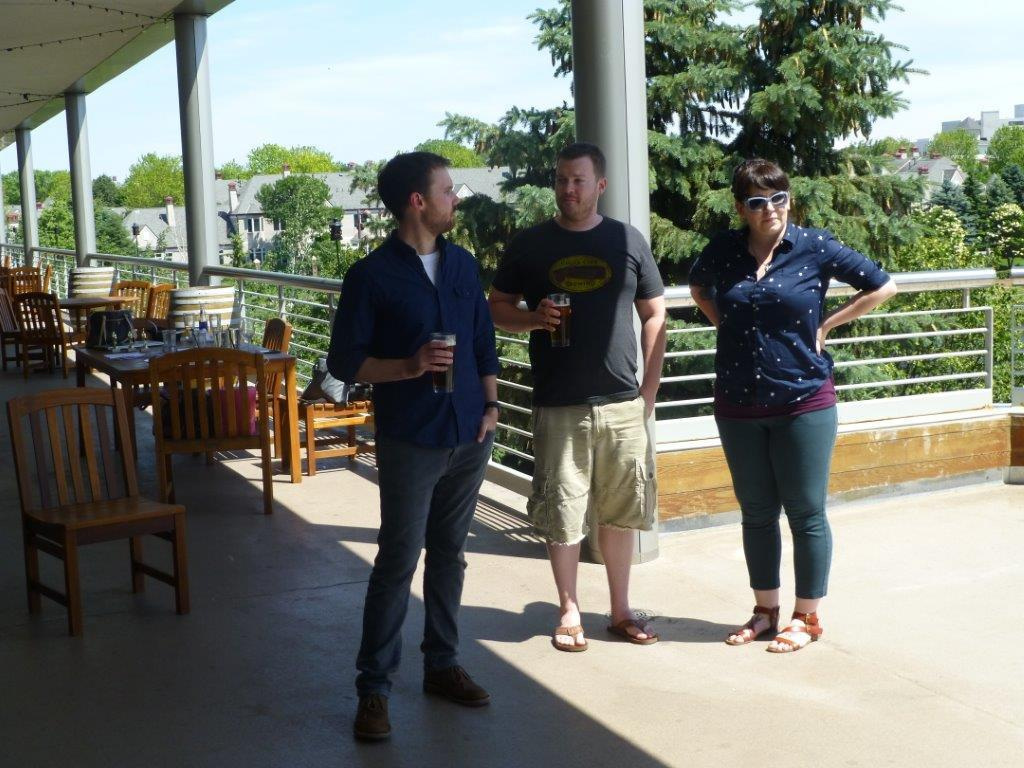What can be seen in the image? There are people standing in the image. What objects are visible in the background? There are chairs, tables, trees, and buildings in the background of the image. What is visible in the sky? The sky is visible in the image. What type of grass is growing on the cup in the image? There is no cup or grass present in the image. 